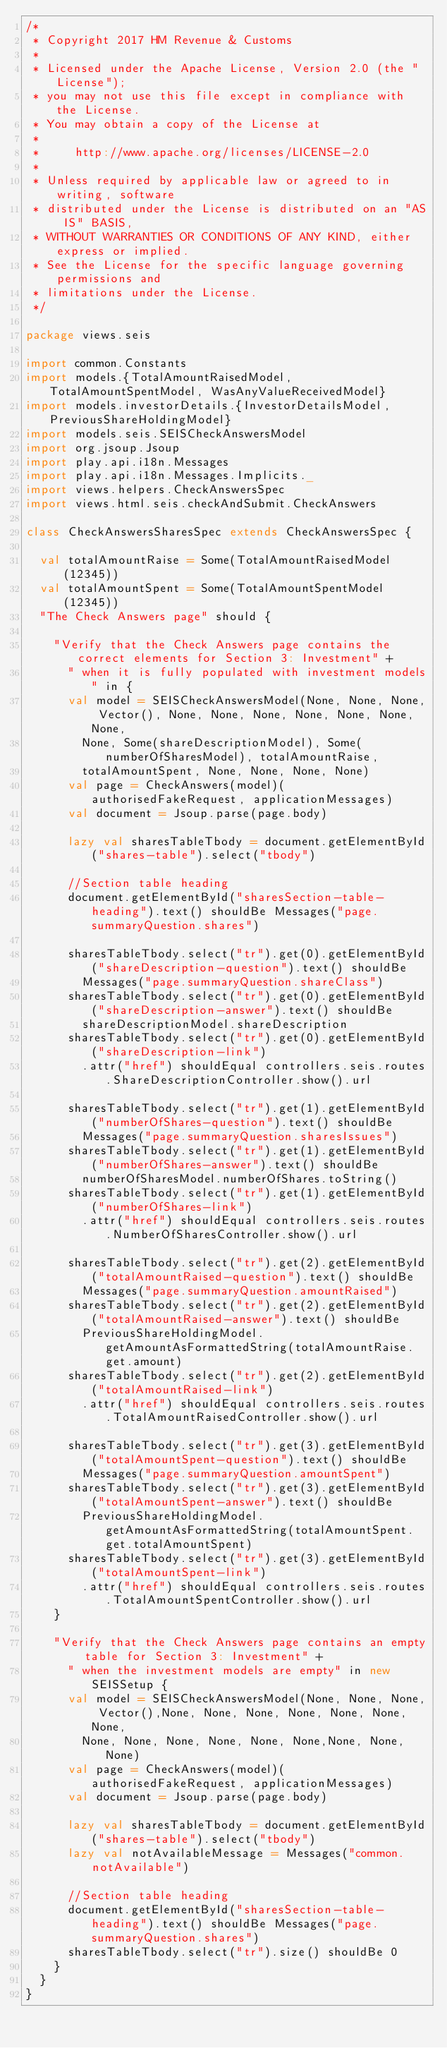<code> <loc_0><loc_0><loc_500><loc_500><_Scala_>/*
 * Copyright 2017 HM Revenue & Customs
 *
 * Licensed under the Apache License, Version 2.0 (the "License");
 * you may not use this file except in compliance with the License.
 * You may obtain a copy of the License at
 *
 *     http://www.apache.org/licenses/LICENSE-2.0
 *
 * Unless required by applicable law or agreed to in writing, software
 * distributed under the License is distributed on an "AS IS" BASIS,
 * WITHOUT WARRANTIES OR CONDITIONS OF ANY KIND, either express or implied.
 * See the License for the specific language governing permissions and
 * limitations under the License.
 */

package views.seis

import common.Constants
import models.{TotalAmountRaisedModel, TotalAmountSpentModel, WasAnyValueReceivedModel}
import models.investorDetails.{InvestorDetailsModel, PreviousShareHoldingModel}
import models.seis.SEISCheckAnswersModel
import org.jsoup.Jsoup
import play.api.i18n.Messages
import play.api.i18n.Messages.Implicits._
import views.helpers.CheckAnswersSpec
import views.html.seis.checkAndSubmit.CheckAnswers

class CheckAnswersSharesSpec extends CheckAnswersSpec {

  val totalAmountRaise = Some(TotalAmountRaisedModel(12345))
  val totalAmountSpent = Some(TotalAmountSpentModel(12345))
  "The Check Answers page" should {

    "Verify that the Check Answers page contains the correct elements for Section 3: Investment" +
      " when it is fully populated with investment models" in {
      val model = SEISCheckAnswersModel(None, None, None, Vector(), None, None, None, None, None, None, None,
        None, Some(shareDescriptionModel), Some(numberOfSharesModel), totalAmountRaise,
        totalAmountSpent, None, None, None, None)
      val page = CheckAnswers(model)(authorisedFakeRequest, applicationMessages)
      val document = Jsoup.parse(page.body)

      lazy val sharesTableTbody = document.getElementById("shares-table").select("tbody")

      //Section table heading
      document.getElementById("sharesSection-table-heading").text() shouldBe Messages("page.summaryQuestion.shares")

      sharesTableTbody.select("tr").get(0).getElementById("shareDescription-question").text() shouldBe
        Messages("page.summaryQuestion.shareClass")
      sharesTableTbody.select("tr").get(0).getElementById("shareDescription-answer").text() shouldBe
        shareDescriptionModel.shareDescription
      sharesTableTbody.select("tr").get(0).getElementById("shareDescription-link")
        .attr("href") shouldEqual controllers.seis.routes.ShareDescriptionController.show().url

      sharesTableTbody.select("tr").get(1).getElementById("numberOfShares-question").text() shouldBe
        Messages("page.summaryQuestion.sharesIssues")
      sharesTableTbody.select("tr").get(1).getElementById("numberOfShares-answer").text() shouldBe
        numberOfSharesModel.numberOfShares.toString()
      sharesTableTbody.select("tr").get(1).getElementById("numberOfShares-link")
        .attr("href") shouldEqual controllers.seis.routes.NumberOfSharesController.show().url

      sharesTableTbody.select("tr").get(2).getElementById("totalAmountRaised-question").text() shouldBe
        Messages("page.summaryQuestion.amountRaised")
      sharesTableTbody.select("tr").get(2).getElementById("totalAmountRaised-answer").text() shouldBe
        PreviousShareHoldingModel.getAmountAsFormattedString(totalAmountRaise.get.amount)
      sharesTableTbody.select("tr").get(2).getElementById("totalAmountRaised-link")
        .attr("href") shouldEqual controllers.seis.routes.TotalAmountRaisedController.show().url

      sharesTableTbody.select("tr").get(3).getElementById("totalAmountSpent-question").text() shouldBe
        Messages("page.summaryQuestion.amountSpent")
      sharesTableTbody.select("tr").get(3).getElementById("totalAmountSpent-answer").text() shouldBe
        PreviousShareHoldingModel.getAmountAsFormattedString(totalAmountSpent.get.totalAmountSpent)
      sharesTableTbody.select("tr").get(3).getElementById("totalAmountSpent-link")
        .attr("href") shouldEqual controllers.seis.routes.TotalAmountSpentController.show().url
    }

    "Verify that the Check Answers page contains an empty table for Section 3: Investment" +
      " when the investment models are empty" in new SEISSetup {
      val model = SEISCheckAnswersModel(None, None, None, Vector(),None, None, None, None, None, None, None,
        None, None, None, None, None, None,None, None, None)
      val page = CheckAnswers(model)(authorisedFakeRequest, applicationMessages)
      val document = Jsoup.parse(page.body)

      lazy val sharesTableTbody = document.getElementById("shares-table").select("tbody")
      lazy val notAvailableMessage = Messages("common.notAvailable")

      //Section table heading
      document.getElementById("sharesSection-table-heading").text() shouldBe Messages("page.summaryQuestion.shares")
      sharesTableTbody.select("tr").size() shouldBe 0
    }
  }
}

</code> 